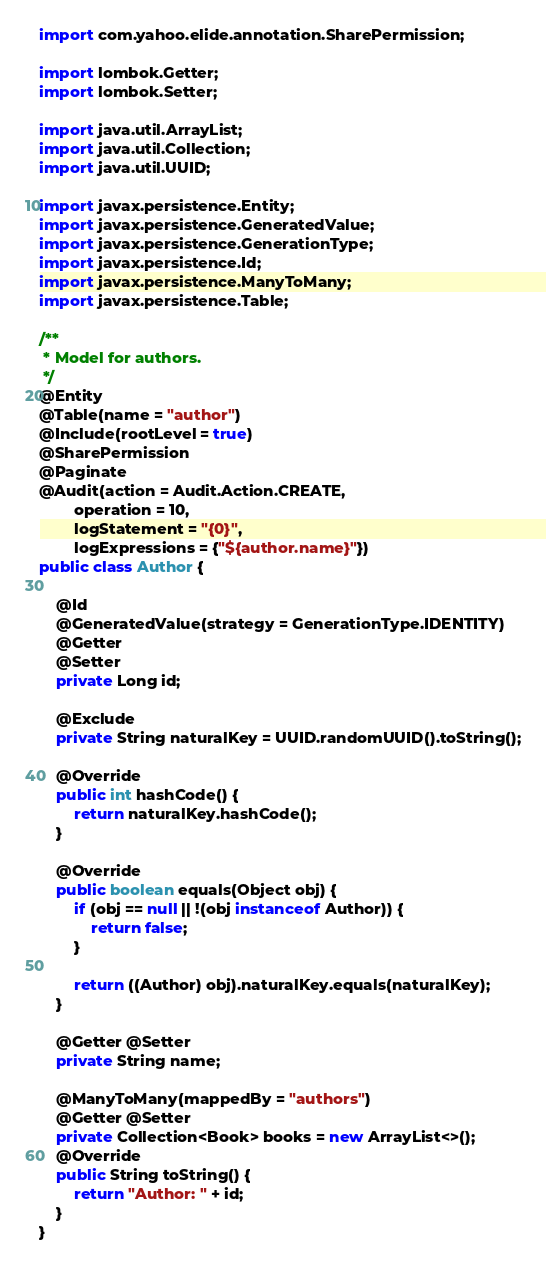<code> <loc_0><loc_0><loc_500><loc_500><_Java_>import com.yahoo.elide.annotation.SharePermission;

import lombok.Getter;
import lombok.Setter;

import java.util.ArrayList;
import java.util.Collection;
import java.util.UUID;

import javax.persistence.Entity;
import javax.persistence.GeneratedValue;
import javax.persistence.GenerationType;
import javax.persistence.Id;
import javax.persistence.ManyToMany;
import javax.persistence.Table;

/**
 * Model for authors.
 */
@Entity
@Table(name = "author")
@Include(rootLevel = true)
@SharePermission
@Paginate
@Audit(action = Audit.Action.CREATE,
        operation = 10,
        logStatement = "{0}",
        logExpressions = {"${author.name}"})
public class Author {

    @Id
    @GeneratedValue(strategy = GenerationType.IDENTITY)
    @Getter
    @Setter
    private Long id;

    @Exclude
    private String naturalKey = UUID.randomUUID().toString();

    @Override
    public int hashCode() {
        return naturalKey.hashCode();
    }

    @Override
    public boolean equals(Object obj) {
        if (obj == null || !(obj instanceof Author)) {
            return false;
        }

        return ((Author) obj).naturalKey.equals(naturalKey);
    }

    @Getter @Setter
    private String name;

    @ManyToMany(mappedBy = "authors")
    @Getter @Setter
    private Collection<Book> books = new ArrayList<>();
    @Override
    public String toString() {
        return "Author: " + id;
    }
}
</code> 